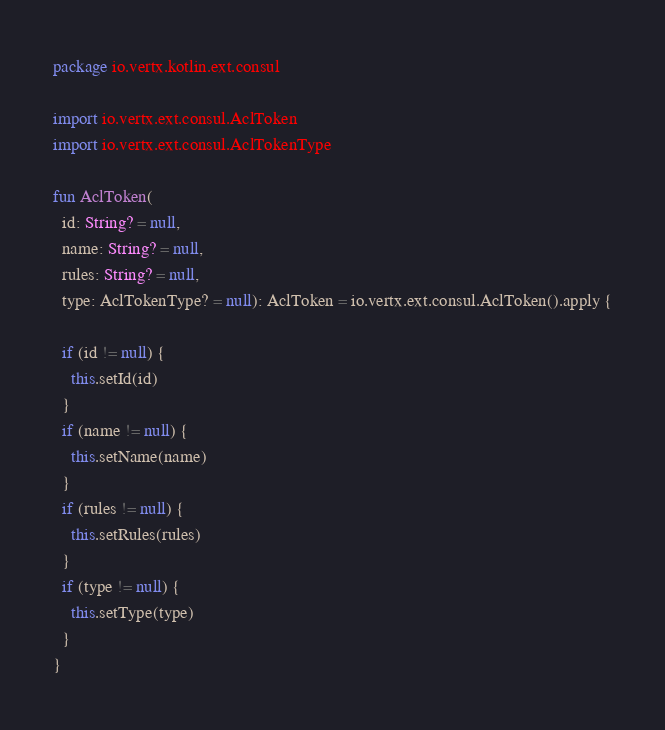<code> <loc_0><loc_0><loc_500><loc_500><_Kotlin_>package io.vertx.kotlin.ext.consul

import io.vertx.ext.consul.AclToken
import io.vertx.ext.consul.AclTokenType

fun AclToken(
  id: String? = null,
  name: String? = null,
  rules: String? = null,
  type: AclTokenType? = null): AclToken = io.vertx.ext.consul.AclToken().apply {

  if (id != null) {
    this.setId(id)
  }
  if (name != null) {
    this.setName(name)
  }
  if (rules != null) {
    this.setRules(rules)
  }
  if (type != null) {
    this.setType(type)
  }
}

</code> 